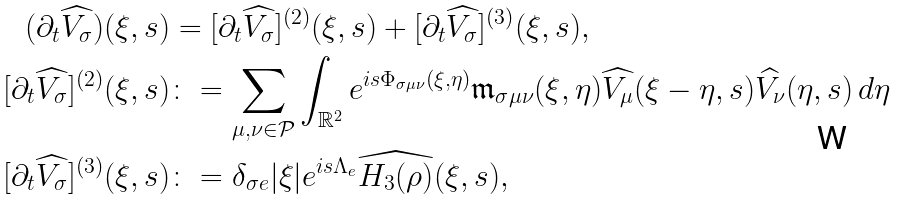<formula> <loc_0><loc_0><loc_500><loc_500>( \partial _ { t } \widehat { V _ { \sigma } } ) ( \xi , s ) & = [ \partial _ { t } \widehat { V _ { \sigma } } ] ^ { ( 2 ) } ( \xi , s ) + [ \partial _ { t } \widehat { V _ { \sigma } } ] ^ { ( 3 ) } ( \xi , s ) , \\ [ \partial _ { t } \widehat { V _ { \sigma } } ] ^ { ( 2 ) } ( \xi , s ) & \colon = \sum _ { \mu , \nu \in \mathcal { P } } \int _ { \mathbb { R } ^ { 2 } } e ^ { i s \Phi _ { \sigma \mu \nu } ( \xi , \eta ) } \mathfrak { m } _ { \sigma \mu \nu } ( \xi , \eta ) \widehat { V _ { \mu } } ( \xi - \eta , s ) \widehat { V _ { \nu } } ( \eta , s ) \, d \eta \\ [ \partial _ { t } \widehat { V _ { \sigma } } ] ^ { ( 3 ) } ( \xi , s ) & \colon = \delta _ { \sigma e } | \xi | e ^ { i s \Lambda _ { e } } \widehat { H _ { 3 } ( \rho ) } ( \xi , s ) ,</formula> 